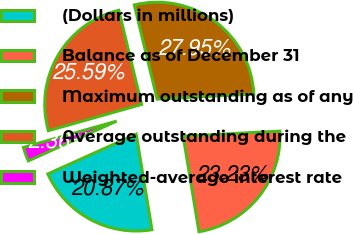<chart> <loc_0><loc_0><loc_500><loc_500><pie_chart><fcel>(Dollars in millions)<fcel>Balance as of December 31<fcel>Maximum outstanding as of any<fcel>Average outstanding during the<fcel>Weighted-average interest rate<nl><fcel>20.87%<fcel>23.23%<fcel>27.95%<fcel>25.59%<fcel>2.36%<nl></chart> 